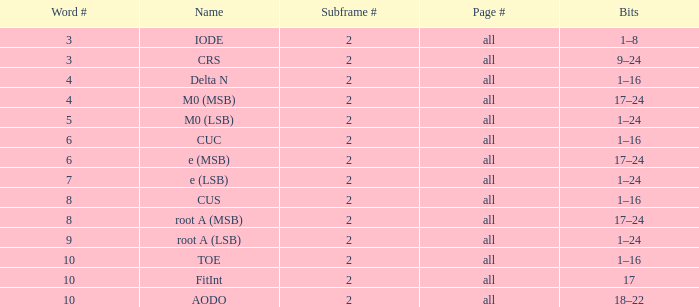What is the page count and word count greater than 5 with Bits of 18–22? All. 